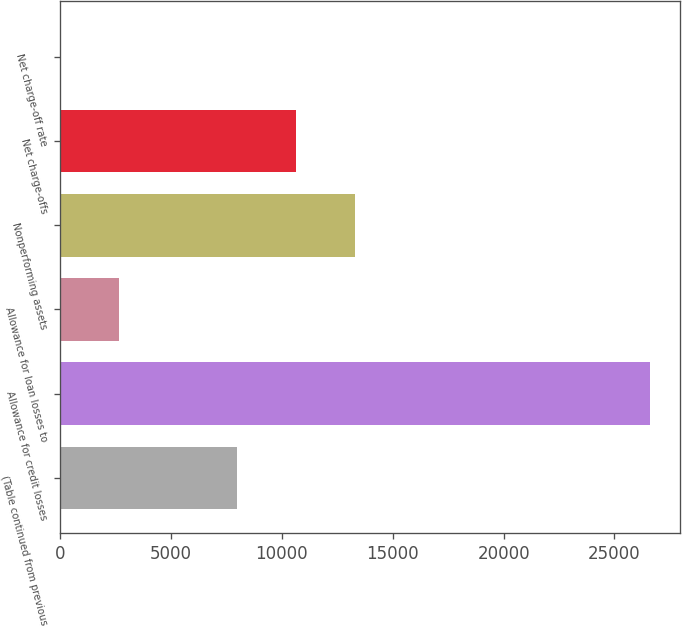Convert chart. <chart><loc_0><loc_0><loc_500><loc_500><bar_chart><fcel>(Table continued from previous<fcel>Allowance for credit losses<fcel>Allowance for loan losses to<fcel>Nonperforming assets<fcel>Net charge-offs<fcel>Net charge-off rate<nl><fcel>7987.24<fcel>26621<fcel>2663.32<fcel>13311.2<fcel>10649.2<fcel>1.35<nl></chart> 